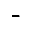Convert formula to latex. <formula><loc_0><loc_0><loc_500><loc_500>-</formula> 